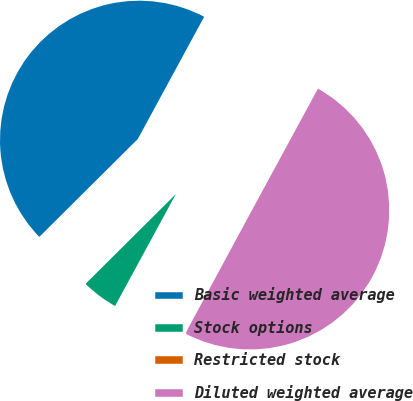Convert chart to OTSL. <chart><loc_0><loc_0><loc_500><loc_500><pie_chart><fcel>Basic weighted average<fcel>Stock options<fcel>Restricted stock<fcel>Diluted weighted average<nl><fcel>45.37%<fcel>4.63%<fcel>0.03%<fcel>49.97%<nl></chart> 